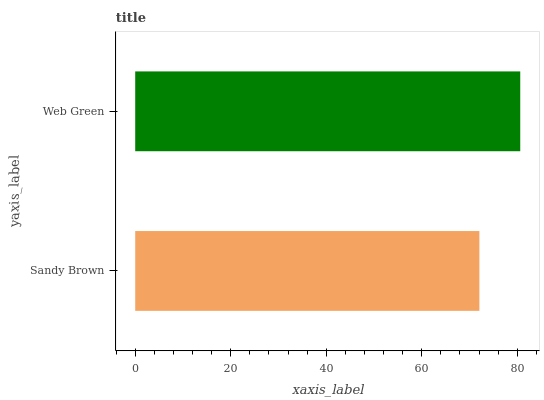Is Sandy Brown the minimum?
Answer yes or no. Yes. Is Web Green the maximum?
Answer yes or no. Yes. Is Web Green the minimum?
Answer yes or no. No. Is Web Green greater than Sandy Brown?
Answer yes or no. Yes. Is Sandy Brown less than Web Green?
Answer yes or no. Yes. Is Sandy Brown greater than Web Green?
Answer yes or no. No. Is Web Green less than Sandy Brown?
Answer yes or no. No. Is Web Green the high median?
Answer yes or no. Yes. Is Sandy Brown the low median?
Answer yes or no. Yes. Is Sandy Brown the high median?
Answer yes or no. No. Is Web Green the low median?
Answer yes or no. No. 